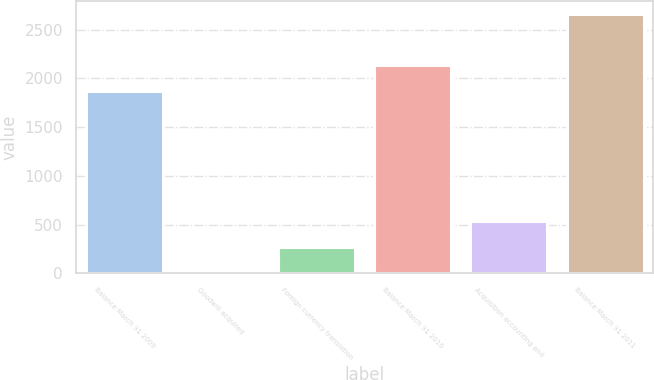Convert chart. <chart><loc_0><loc_0><loc_500><loc_500><bar_chart><fcel>Balance March 31 2009<fcel>Goodwill acquired<fcel>Foreign currency translation<fcel>Balance March 31 2010<fcel>Acquisition accounting and<fcel>Balance March 31 2011<nl><fcel>1869<fcel>7<fcel>272.5<fcel>2134.5<fcel>538<fcel>2662<nl></chart> 